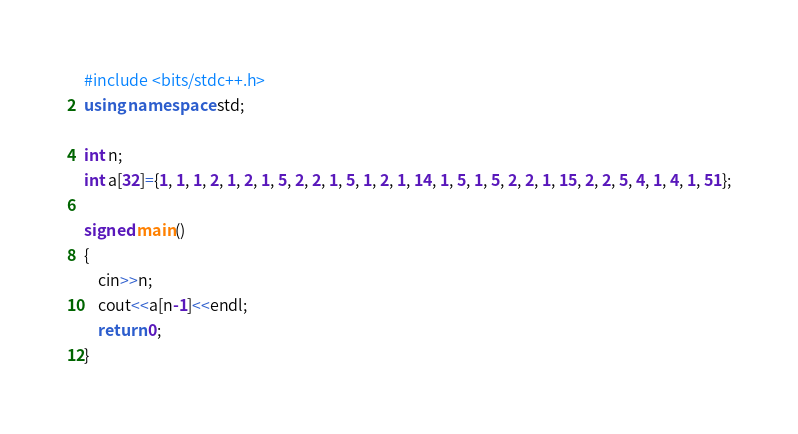Convert code to text. <code><loc_0><loc_0><loc_500><loc_500><_C++_>#include <bits/stdc++.h>
using namespace std;

int n;
int a[32]={1, 1, 1, 2, 1, 2, 1, 5, 2, 2, 1, 5, 1, 2, 1, 14, 1, 5, 1, 5, 2, 2, 1, 15, 2, 2, 5, 4, 1, 4, 1, 51};

signed main()
{
	cin>>n;
	cout<<a[n-1]<<endl;
	return 0;
}</code> 